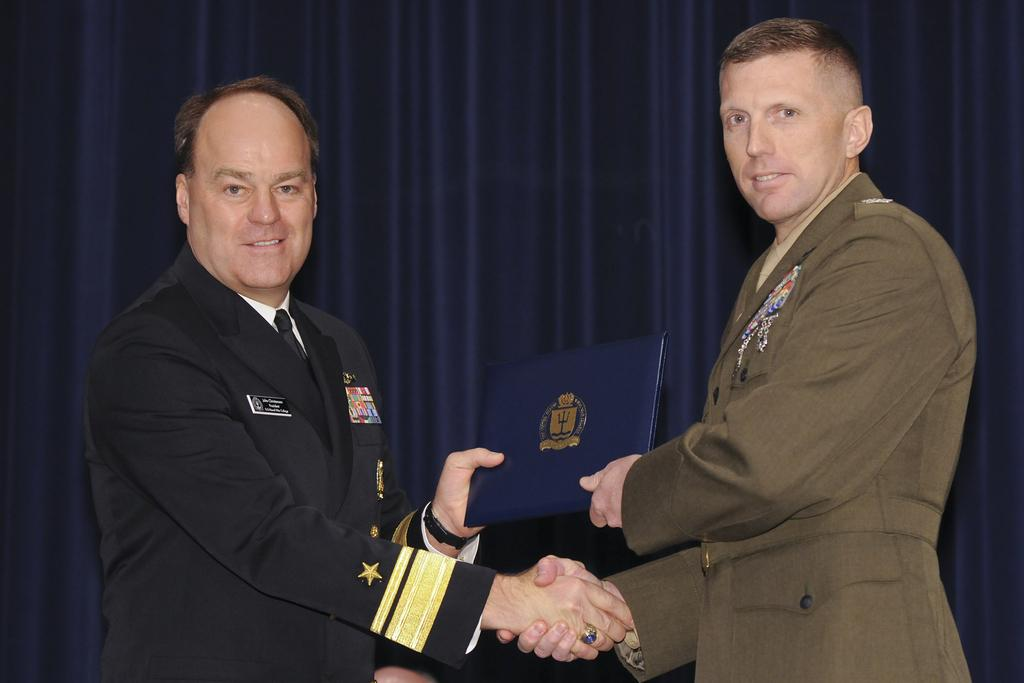How many people are in the image? There are two people in the image. What are the two people doing? The two people are giving each other a handshake. What else are the two people holding in the image? The two people are holding an object. What can be seen in the background of the image? There is a blue curtain in the background of the image. What type of soda is being poured into the baseball in the image? There is no soda or baseball present in the image. Can you tell me how many bones are visible in the image? There are no bones visible in the image. 